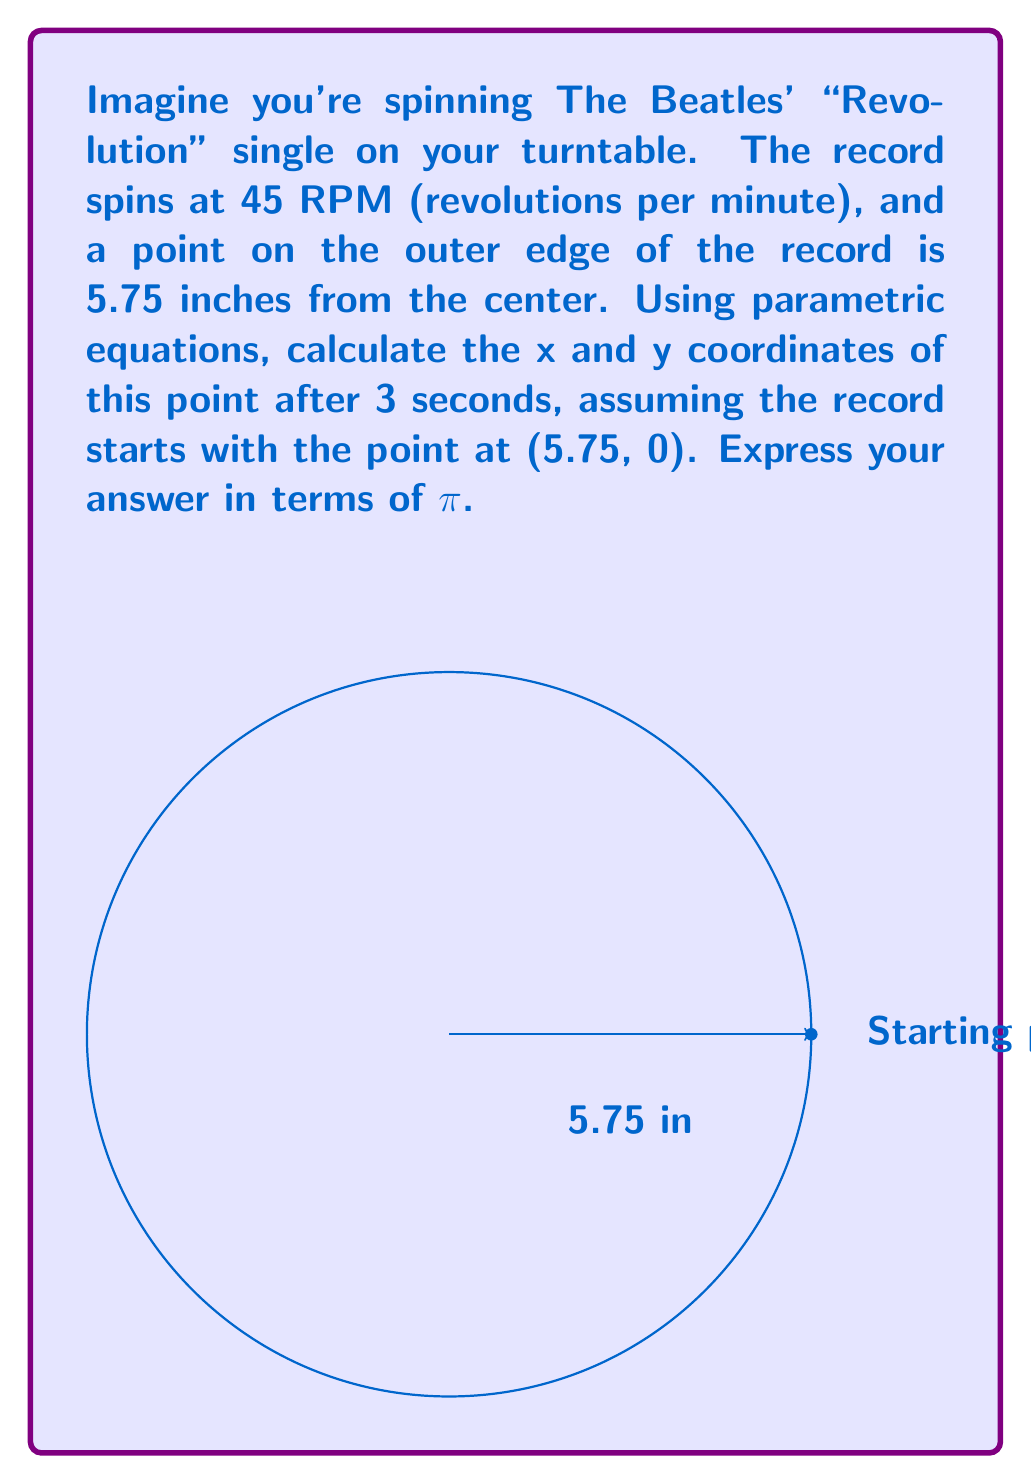Provide a solution to this math problem. Let's approach this step-by-step:

1) First, we need to convert the rotation speed from RPM to radians per second:
   45 RPM = 45 * (2π rad) / (60 sec) = 3π/2 rad/sec

2) The angular displacement after 3 seconds is:
   θ = (3π/2) * 3 = 9π/2 radians

3) The parametric equations for a point (x,y) on a circle with radius r and angle θ are:
   x = r * cos(θ)
   y = r * sin(θ)

4) In this case, r = 5.75 inches and θ = 9π/2 radians

5) Substituting these values:
   x = 5.75 * cos(9π/2)
   y = 5.75 * sin(9π/2)

6) Simplify:
   cos(9π/2) = cos(4π + π/2) = cos(π/2) = 0
   sin(9π/2) = sin(4π + π/2) = sin(π/2) = 1

7) Therefore:
   x = 5.75 * 0 = 0
   y = 5.75 * 1 = 5.75
Answer: (0, 5.75) 